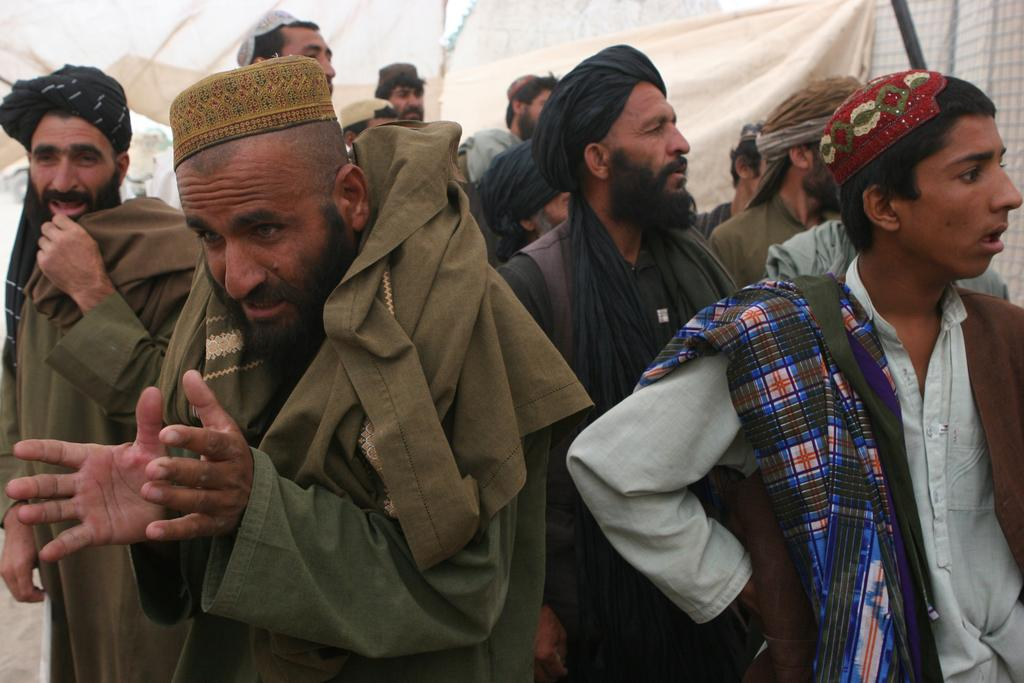How many people are in the image? There is a group of persons in the image. Where are the persons located in the image? The group of persons is standing in the middle of the image. What can be seen in the background of the image? There are curtains in the background of the image. What type of trees can be seen swaying in the waves behind the group of persons? There are no trees or waves present in the image; it only features a group of persons standing in the middle and curtains in the background. 